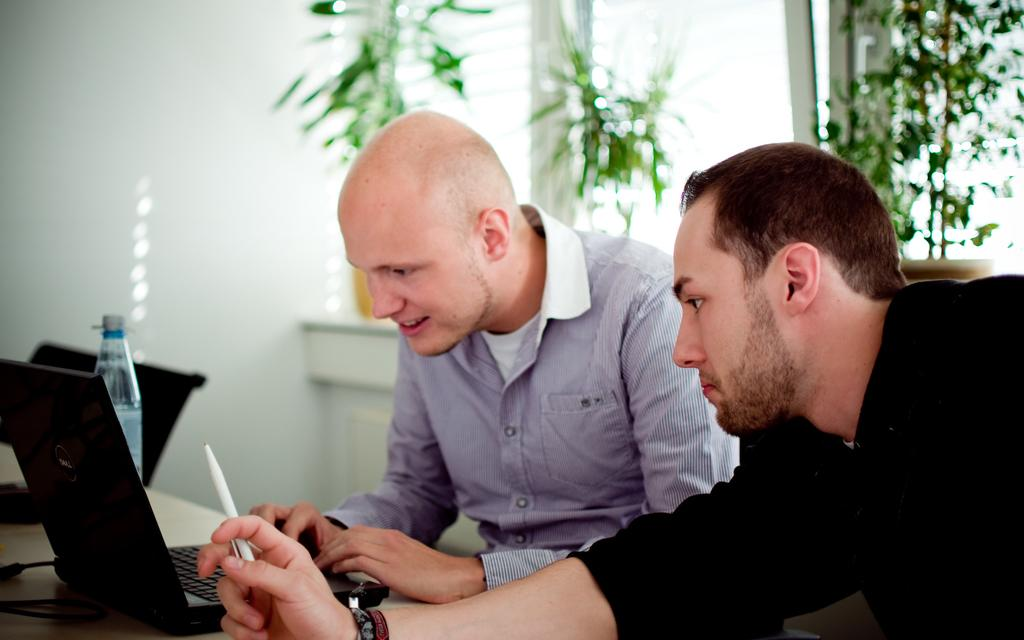How many people are present in the image? There are two persons in the image. What electronic device can be seen in the image? There is a laptop in the image. What else is visible in the image besides the laptop? There are wires, bottles, a wall with windows, plants, and chairs visible in the image. Can you see any rings on the rabbit's ears in the image? There is no rabbit present in the image, and therefore no rings on its ears can be observed. 